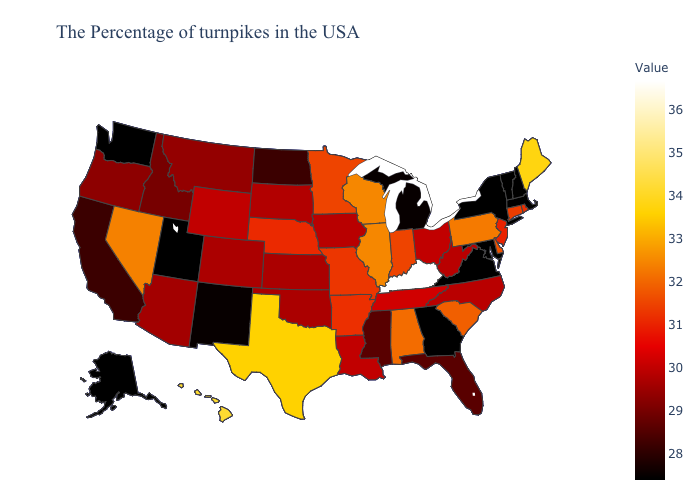Among the states that border Ohio , which have the highest value?
Answer briefly. Kentucky. Among the states that border North Carolina , does South Carolina have the lowest value?
Answer briefly. No. 